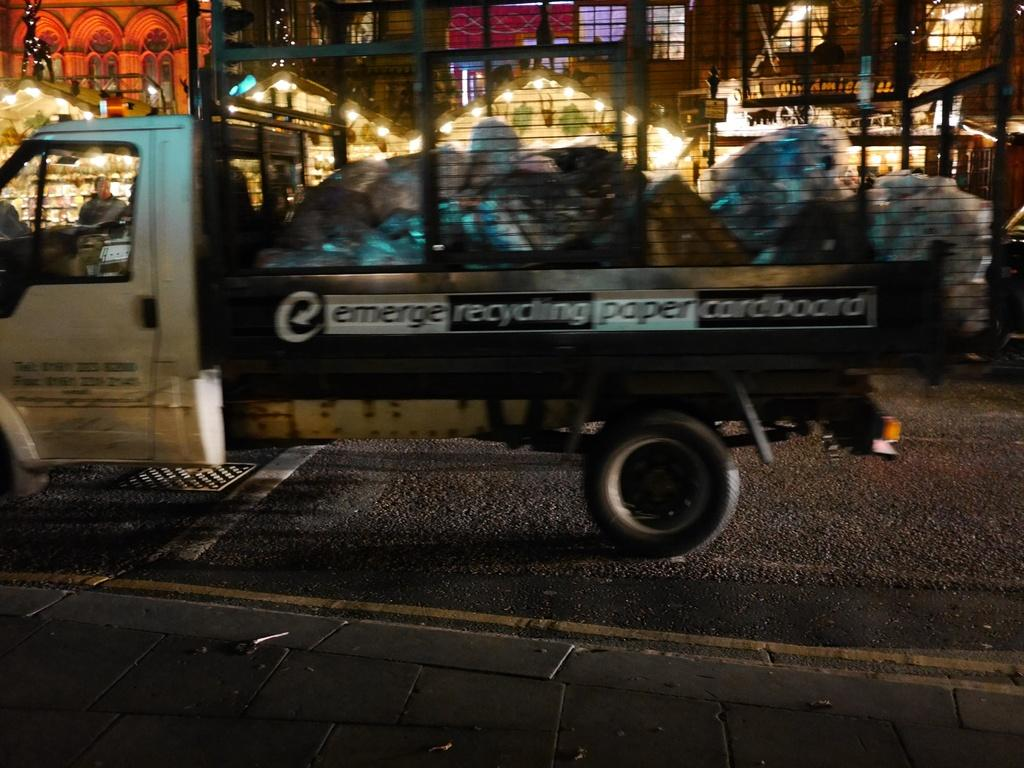What is on the road in the image? There is a vehicle on the road in the image. What can be seen in the distance behind the vehicle? There are buildings and lights in the background. What might be found inside the vehicle? There are things inside the vehicle. What type of gold object can be seen in the vehicle in the image? There is no gold object visible in the vehicle in the image. 